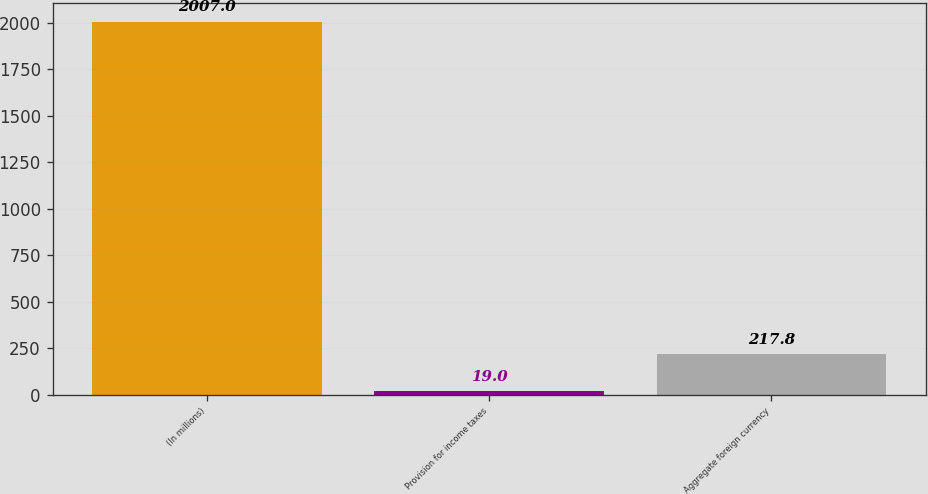<chart> <loc_0><loc_0><loc_500><loc_500><bar_chart><fcel>(In millions)<fcel>Provision for income taxes<fcel>Aggregate foreign currency<nl><fcel>2007<fcel>19<fcel>217.8<nl></chart> 